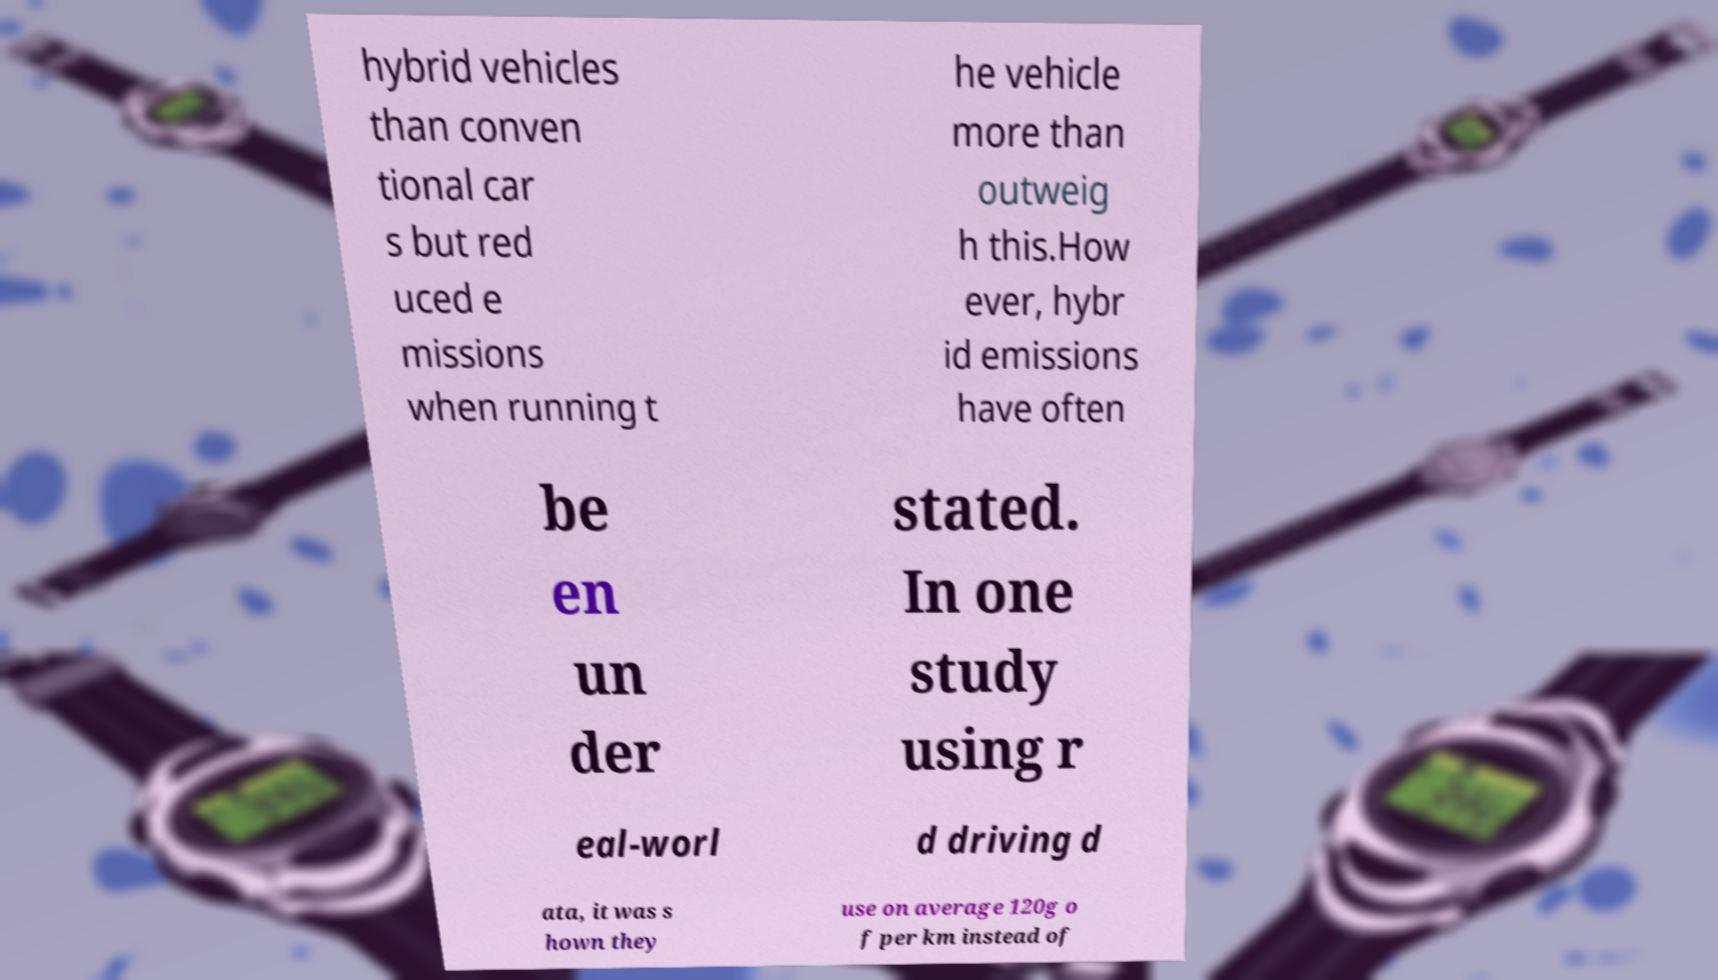Could you assist in decoding the text presented in this image and type it out clearly? hybrid vehicles than conven tional car s but red uced e missions when running t he vehicle more than outweig h this.How ever, hybr id emissions have often be en un der stated. In one study using r eal-worl d driving d ata, it was s hown they use on average 120g o f per km instead of 